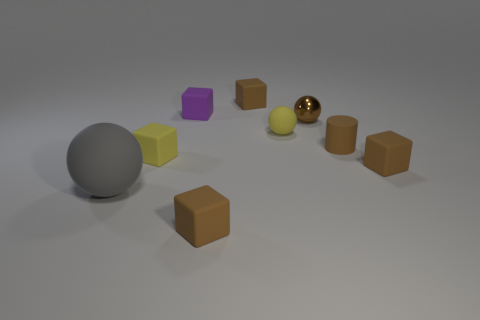The gray rubber object that is in front of the tiny ball that is in front of the small brown metallic object that is behind the brown cylinder is what shape?
Give a very brief answer. Sphere. There is a cylinder that is the same size as the brown ball; what is its color?
Provide a succinct answer. Brown. What number of other big things have the same shape as the purple matte thing?
Your response must be concise. 0. There is a matte cylinder; is it the same size as the rubber block on the right side of the small matte ball?
Offer a very short reply. Yes. What is the shape of the tiny thing that is in front of the matte ball that is on the left side of the purple object?
Make the answer very short. Cube. Is the number of tiny rubber objects in front of the tiny metal thing less than the number of big rubber balls?
Your answer should be compact. No. What shape is the tiny matte object that is the same color as the small matte ball?
Offer a very short reply. Cube. What number of blue metallic balls have the same size as the yellow block?
Provide a succinct answer. 0. The tiny yellow thing in front of the small rubber cylinder has what shape?
Your answer should be very brief. Cube. Are there fewer small rubber cubes than small brown blocks?
Give a very brief answer. No. 